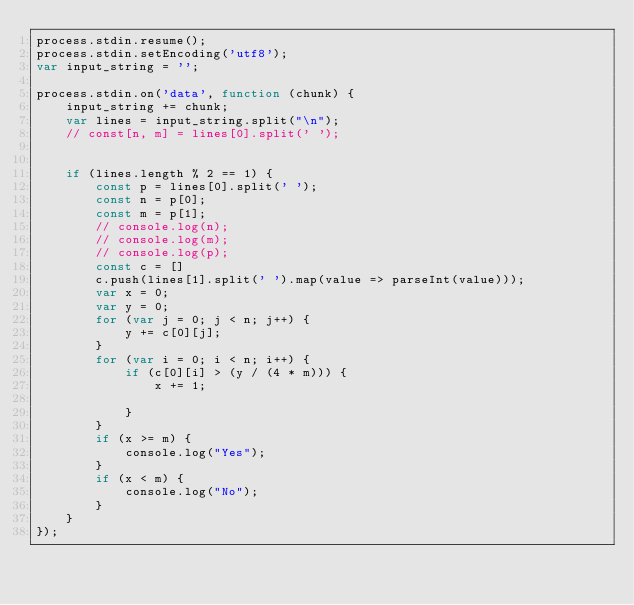<code> <loc_0><loc_0><loc_500><loc_500><_JavaScript_>process.stdin.resume();
process.stdin.setEncoding('utf8');
var input_string = '';

process.stdin.on('data', function (chunk) {
    input_string += chunk;
    var lines = input_string.split("\n");
    // const[n, m] = lines[0].split(' ');


    if (lines.length % 2 == 1) {
        const p = lines[0].split(' ');
        const n = p[0];
        const m = p[1];
        // console.log(n);
        // console.log(m);
        // console.log(p);
        const c = []
        c.push(lines[1].split(' ').map(value => parseInt(value)));
        var x = 0;
        var y = 0;
        for (var j = 0; j < n; j++) {
            y += c[0][j];
        }
        for (var i = 0; i < n; i++) {
            if (c[0][i] > (y / (4 * m))) {
                x += 1;

            }
        }
        if (x >= m) {
            console.log("Yes");
        }
        if (x < m) {
            console.log("No");
        }
    }
});



</code> 